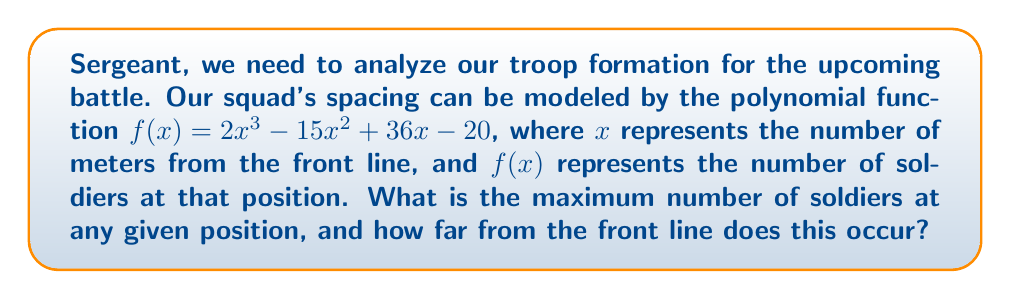Help me with this question. To find the maximum number of soldiers and its position, we need to follow these steps:

1) First, we need to find the derivative of $f(x)$:
   $f'(x) = 6x^2 - 30x + 36$

2) To find the critical points, set $f'(x) = 0$:
   $6x^2 - 30x + 36 = 0$

3) This is a quadratic equation. We can solve it using the quadratic formula:
   $x = \frac{-b \pm \sqrt{b^2 - 4ac}}{2a}$

   Where $a = 6$, $b = -30$, and $c = 36$

4) Plugging in these values:
   $x = \frac{30 \pm \sqrt{900 - 864}}{12} = \frac{30 \pm \sqrt{36}}{12} = \frac{30 \pm 6}{12}$

5) This gives us two critical points:
   $x_1 = \frac{30 + 6}{12} = 3$ and $x_2 = \frac{30 - 6}{12} = 2$

6) To determine which point gives the maximum, we can check the second derivative:
   $f''(x) = 12x - 30$

7) At $x = 3$: $f''(3) = 12(3) - 30 = 6 > 0$, so this is a local minimum.
   At $x = 2$: $f''(2) = 12(2) - 30 = -6 < 0$, so this is a local maximum.

8) Therefore, the maximum occurs at $x = 2$ meters from the front line.

9) To find the number of soldiers at this position, we evaluate $f(2)$:
   $f(2) = 2(2)^3 - 15(2)^2 + 36(2) - 20 = 16 - 60 + 72 - 20 = 8$

Thus, the maximum number of soldiers is 8, occurring 2 meters from the front line.
Answer: 8 soldiers, 2 meters from the front line 